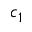Convert formula to latex. <formula><loc_0><loc_0><loc_500><loc_500>c _ { 1 }</formula> 